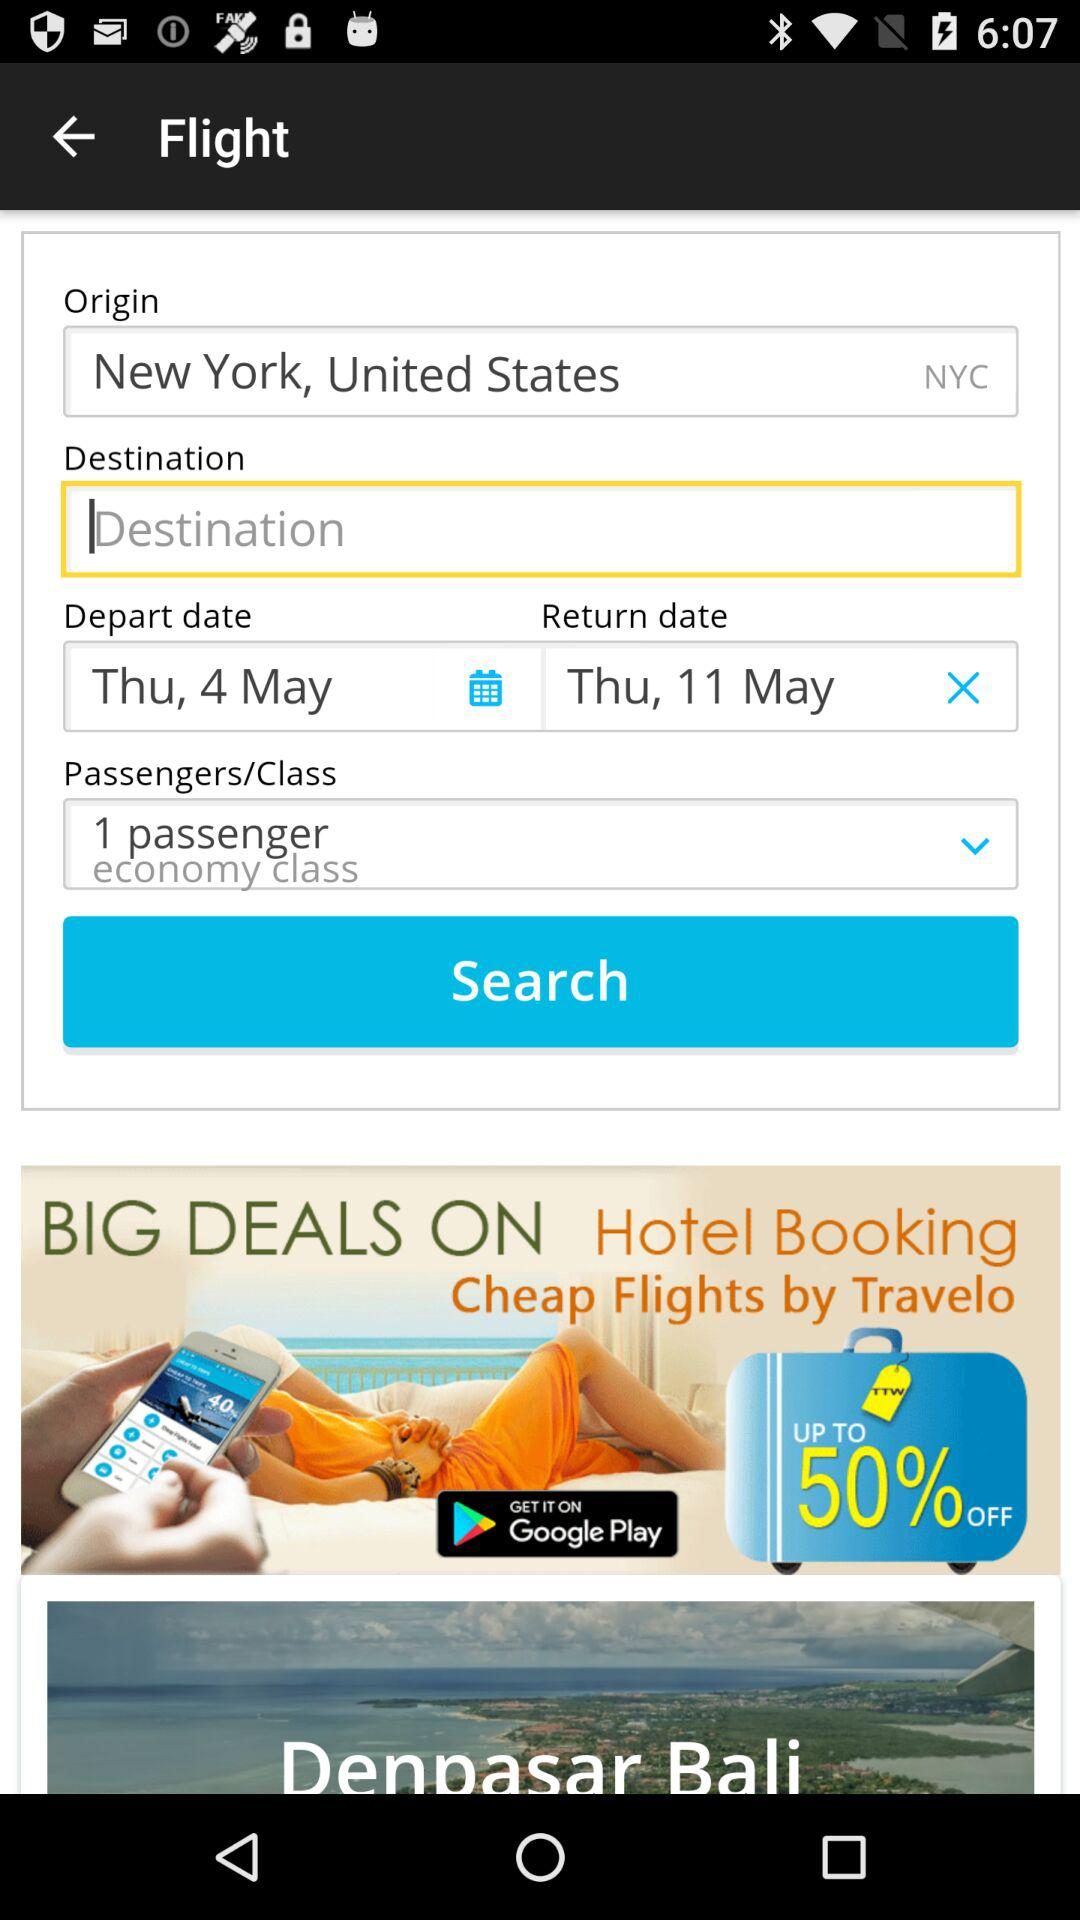How many passengers are there in this booking? The booking shown in the image is for 1 passenger. The booking details specify '1 passenger' under the Passengers/Class section, confirming the number of individuals for this flight reservation. 